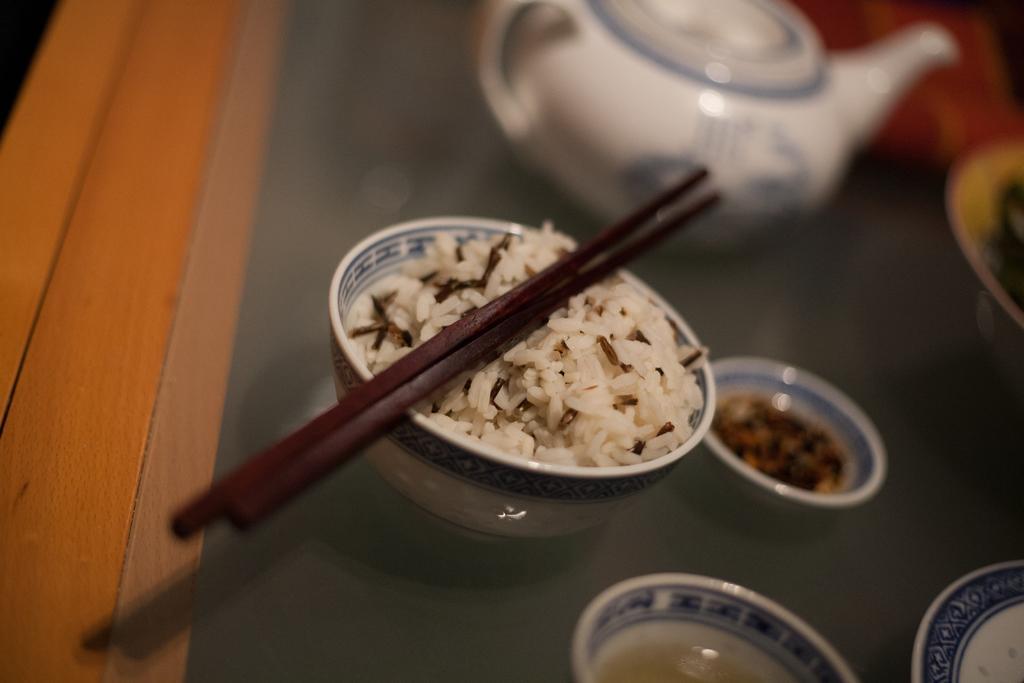Please provide a concise description of this image. In this picture , In the middle there is a bow of white color and it contains rice and there are two stuck in black color and in the background there is a white color object o the yellow color table. 